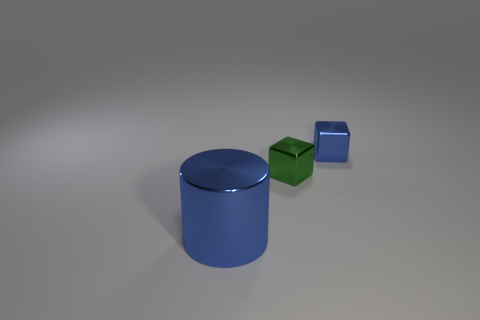Is there anything else that has the same size as the cylinder?
Offer a very short reply. No. The green block has what size?
Offer a terse response. Small. What size is the other thing that is the same shape as the green metallic thing?
Offer a very short reply. Small. What material is the green block?
Ensure brevity in your answer.  Metal. Do the large metal object and the small object that is behind the small green metallic object have the same color?
Provide a short and direct response. Yes. What material is the blue thing in front of the blue object behind the blue thing in front of the tiny green cube?
Offer a terse response. Metal. Do the shiny object behind the small green block and the cylinder have the same color?
Keep it short and to the point. Yes. What shape is the shiny thing that is the same color as the cylinder?
Offer a very short reply. Cube. There is a blue thing on the left side of the tiny metallic thing that is on the right side of the tiny block that is to the left of the tiny blue shiny block; what is its shape?
Your answer should be compact. Cylinder. Is the number of tiny objects in front of the cylinder less than the number of tiny blocks to the right of the tiny green cube?
Ensure brevity in your answer.  Yes. 